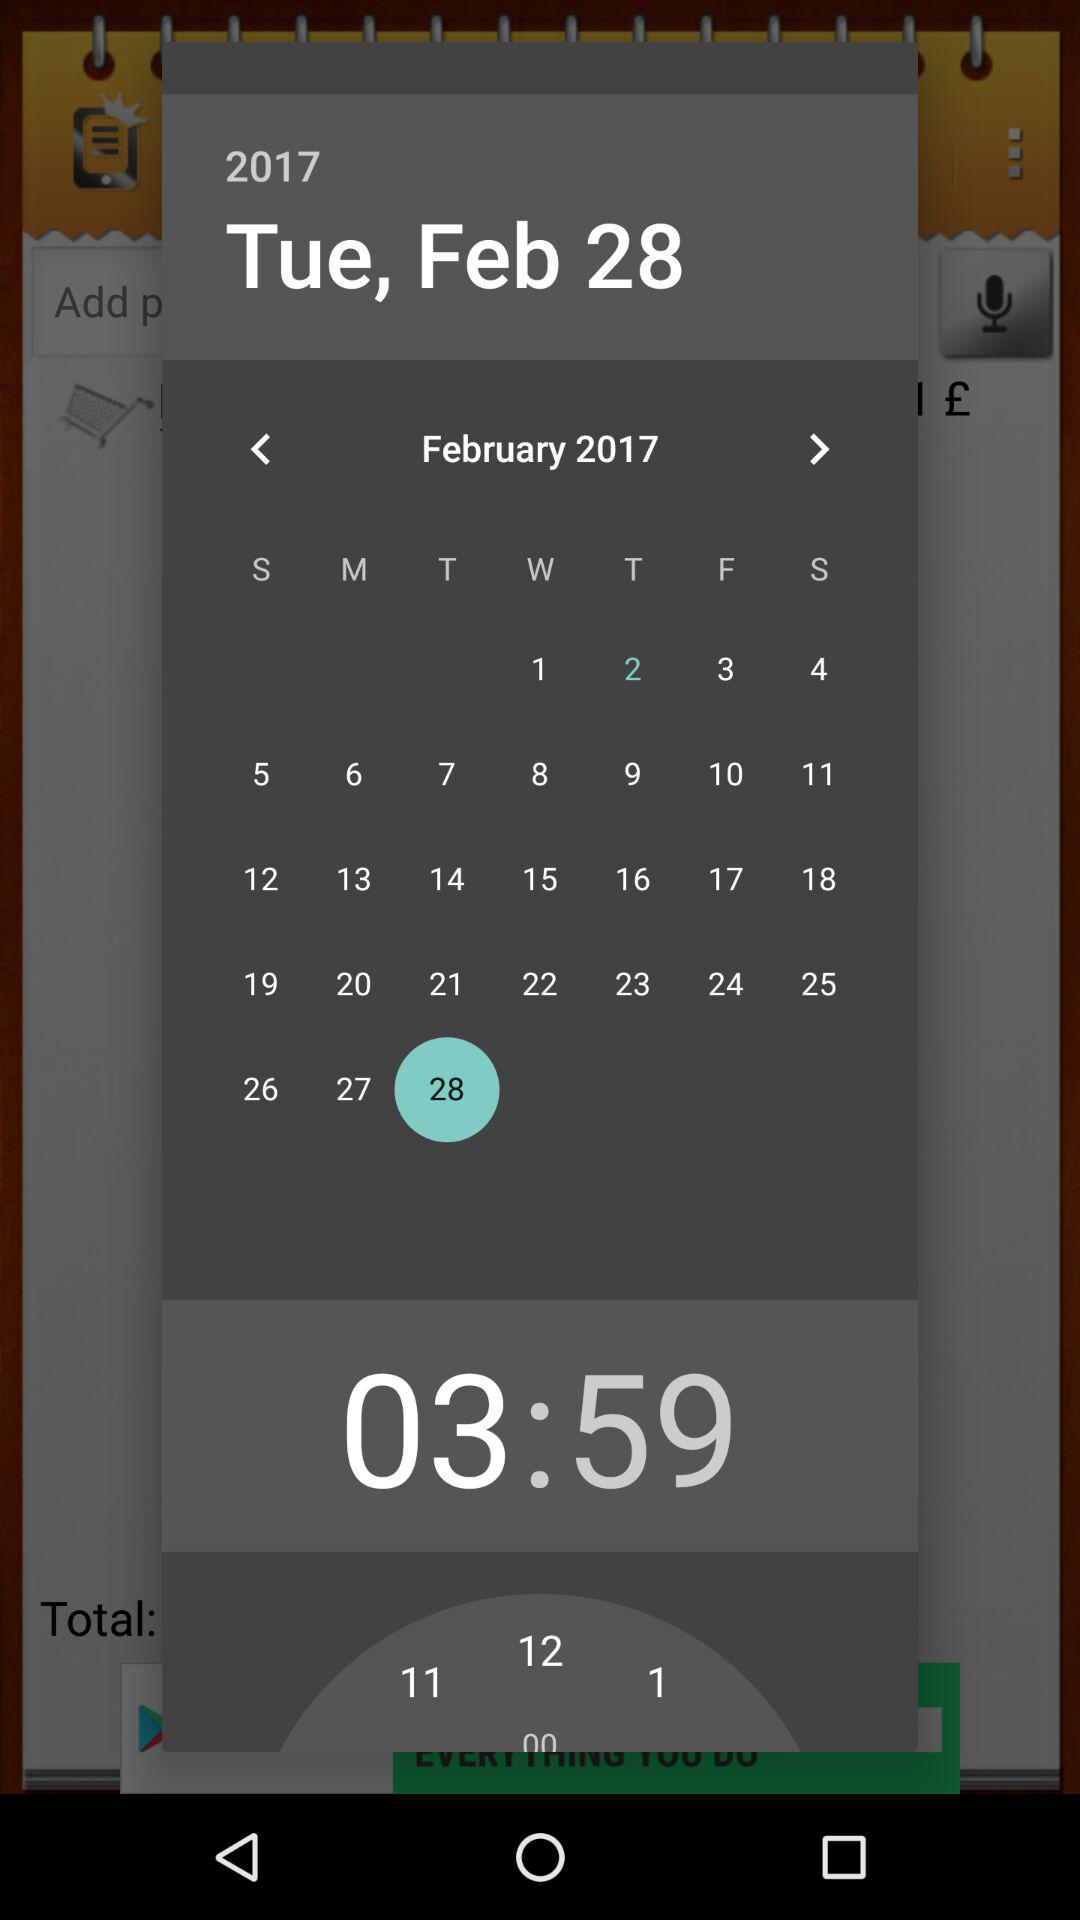What is the day on February 28? The day is Tuesday. 